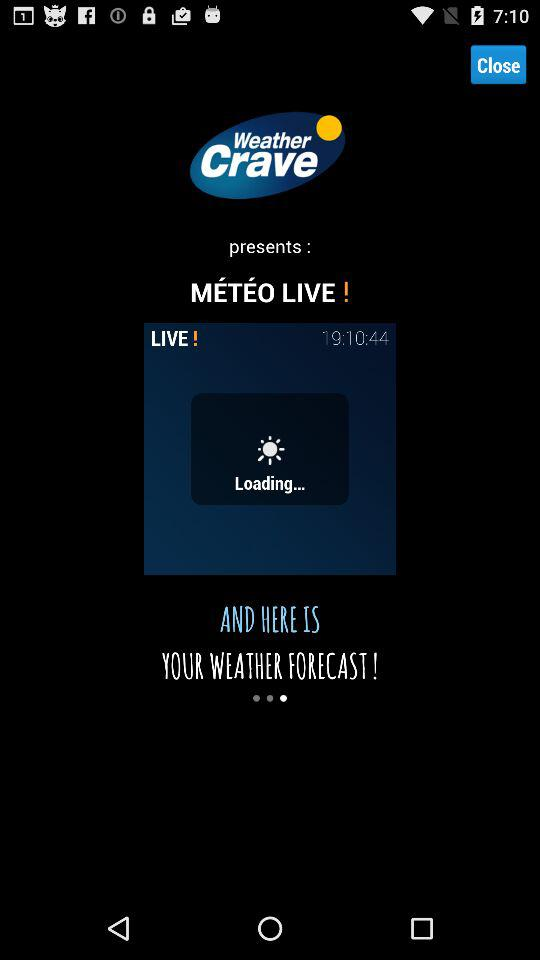What is the application name? The application name is "Weather Crave". 